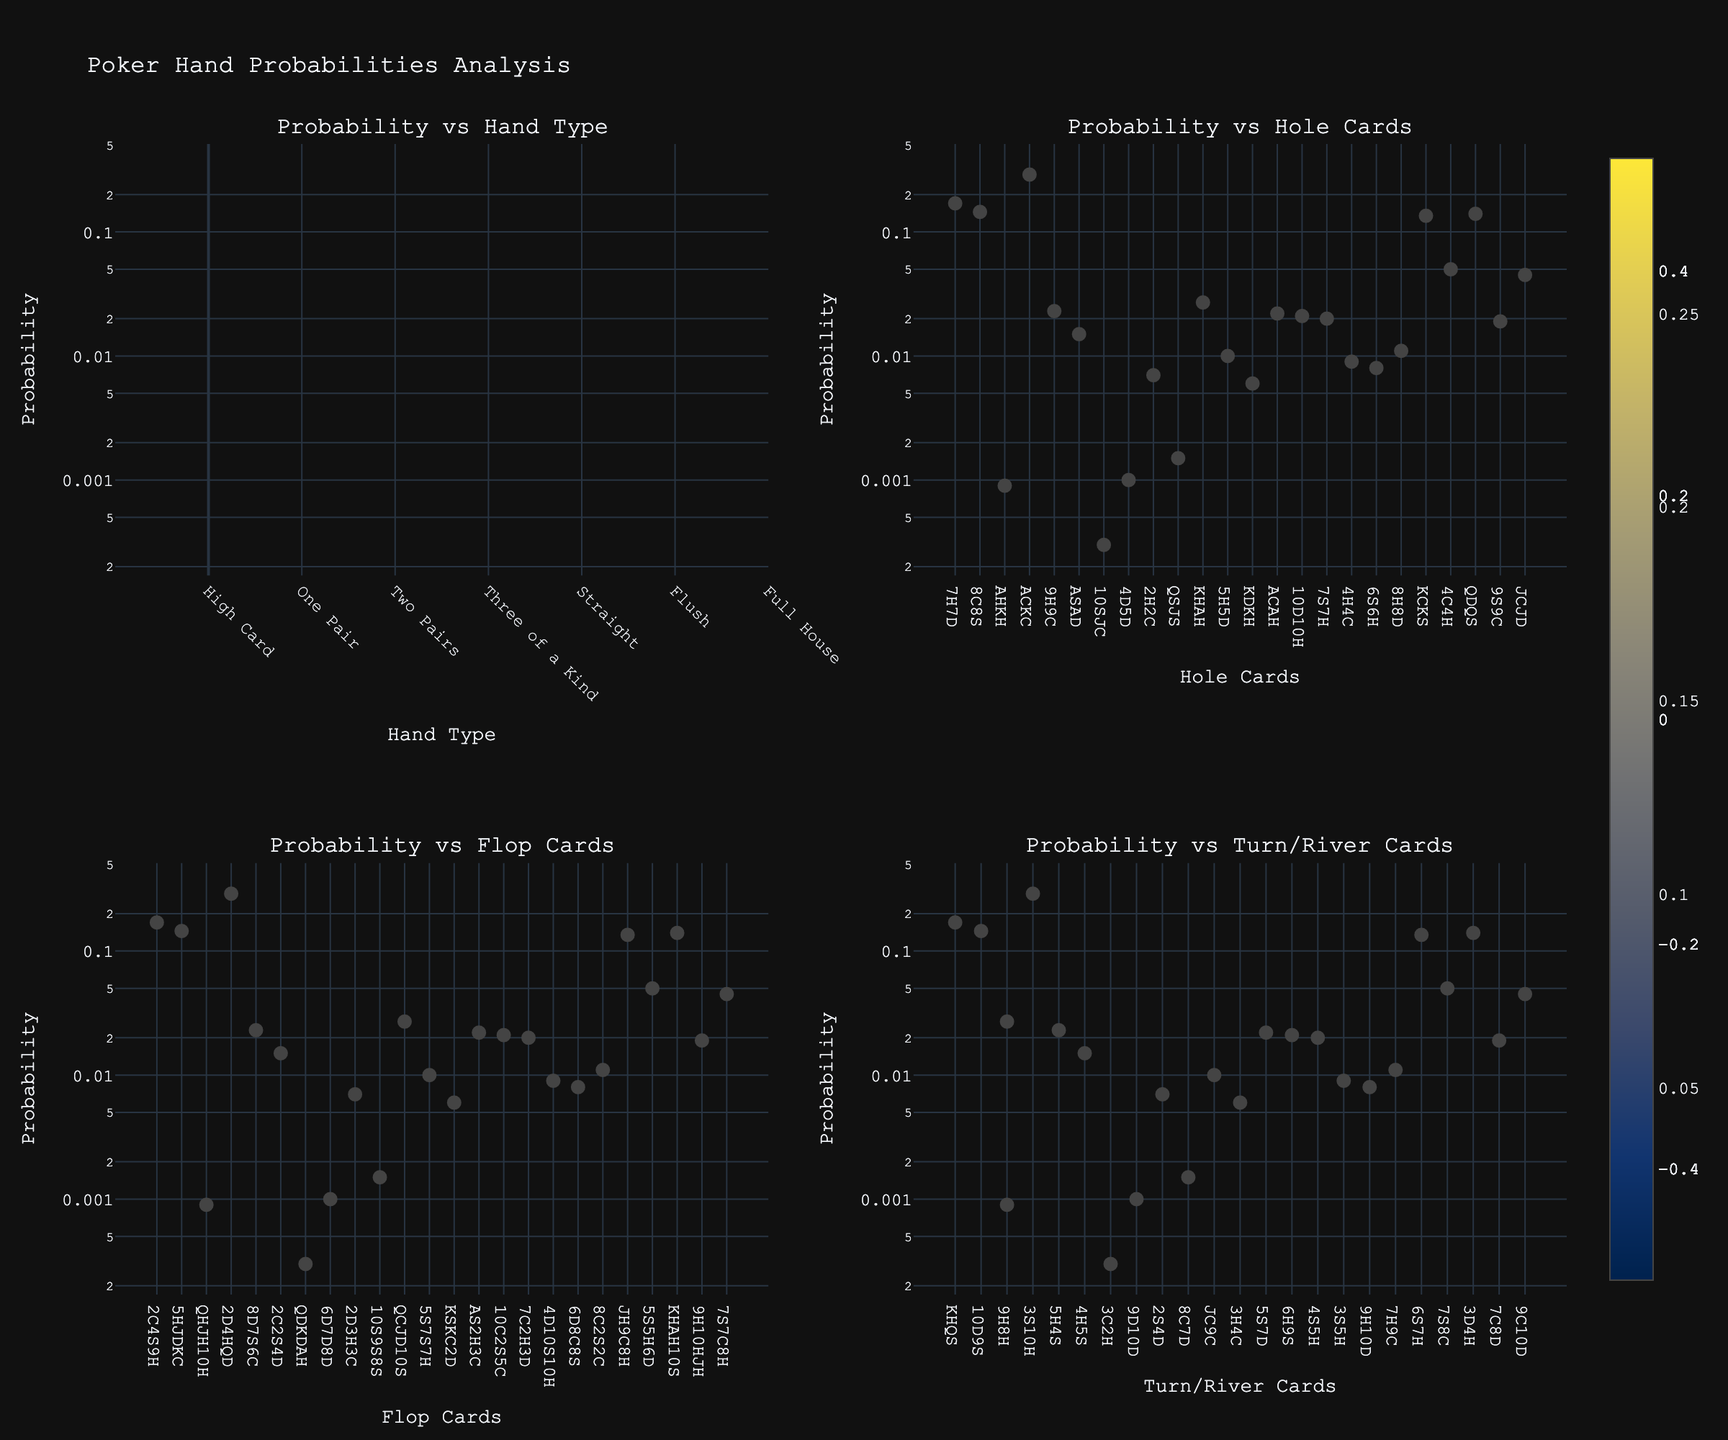What's the title of the figure? The title is typically displayed at the top of the figure, and in this case, it is provided in the code. The title is 'Poker Hand Probabilities Analysis.'
Answer: Poker Hand Probabilities Analysis What is the probability range shown in the color scale for 'Probability vs Hand Type' plot? Based on the visual color scale displayed in the 'Probability vs Hand Type' plot, look at the minimum and maximum values represented by the color gradients from dark to light. The probability ranges from 0.0003 to 0.29.
Answer: 0.0003 to 0.29 How does the 'Probability vs Hand Type' subplot visualize different hand types? The 'Probability vs Hand Type' subplot uses markers where the x-axis labels different hand types and the y-axis shows probability on a logarithmic scale. Hand types are represented by different x-axis labels, and each marker's opacity indicates the probability of that hand type.
Answer: Hand types are labeled on the x-axis with markers representing probabilities Which hand type has the highest probability and what is it? To find which hand type has the highest probability, check the markers that are closest to the top of the y-axis in the 'Probability vs Hand Type' plot. The 'High Card' has the highest probability, which is about 0.29.
Answer: High Card, 0.29 What are the hole cards that appear more frequently with high probabilities? By inspecting the 'Probability vs Hole Cards' subplot, note the cards (x-axis) with markers near the top of the y-axis. The hole cards with high probabilities include combinations like '7H7D' (0.170) and 'KC KS' (0.135).
Answer: 7H7D and KC KS Which combination of turn and river cards shows a relatively high probability of achieving a certain hand type? In the 'Probability vs Turn/River Cards' subplot, look at the markers near the top of the plot. A relatively high probability combination is shown by cards 'KHQS' with a probability of around 0.170.
Answer: KHQS, 0.170 How are the color scales different among the subplots? Each subplot uses a different color scale to represent data. 'Probability vs Hand Type' uses a Viridis color scale, 'Probability vs Hole Cards' uses a Plasma color scale, 'Probability vs Flop Cards' uses an Inferno color scale, and 'Probability vs Turn/River Cards' uses a Cividis color scale.
Answer: Different color scales: Viridis, Plasma, Inferno, Cividis How many unique hand types are represented in the 'Probability vs Hand Type' plot? Count the unique tick labels on the x-axis of the 'Probability vs Hand Type' plot to determine the number of hand types. There are 10 unique hand types displayed.
Answer: 10 Which combination of flop cards has the highest probability of resulting in a specific hand type? In the 'Probability vs Flop Cards' subplot, identify the markers closest to the top on the y-axis. The combination 'QHJH10H' likely has a high probability associated with a subsequent straight flush.
Answer: QHJH10H Which plot shows a logarithmic scale on the y-axis? Observe each subplot for any indications of a logarithmic scale on the y-axis, often denoted by a different spacing between axis ticks. All plots have a logarithmic y-axis as indicated in their setup in the code.
Answer: All plots have a logarithmic y-axis 